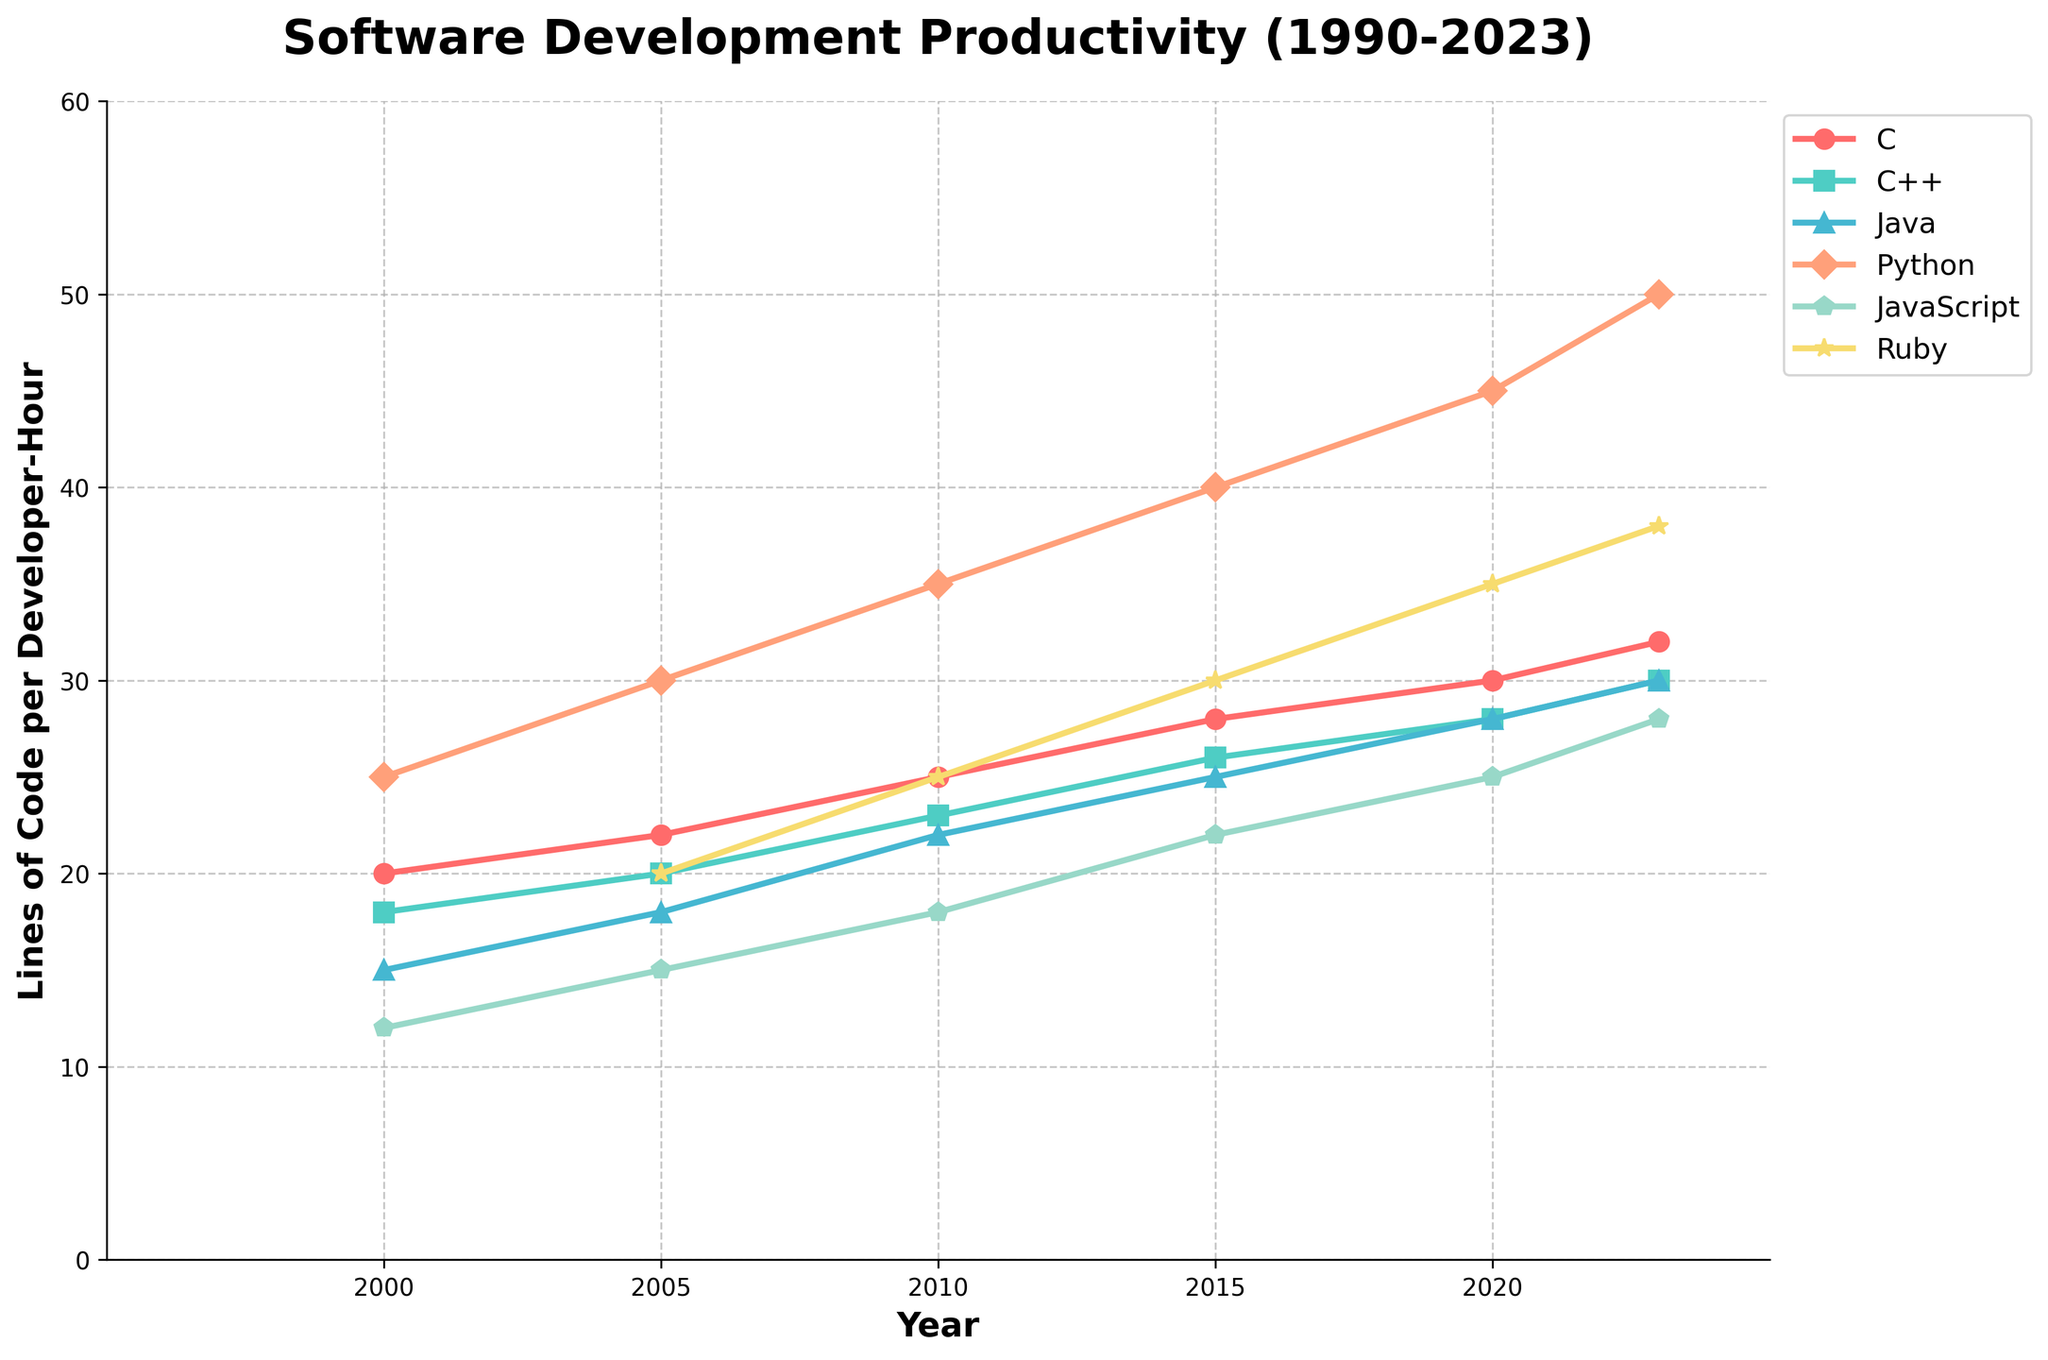What programming language shows the highest productivity in 2023? Locate the year 2023 on the x-axis and find the language with the highest value on the y-axis. Python shows the highest productivity at 50 lines of code per developer-hour.
Answer: Python How did the productivity of JavaScript change from 2000 to 2023? Identify the values for JavaScript in 2000 and 2023. In 2000, it was 12 lines of code per developer-hour, and in 2023, it increased to 28 lines of code per developer-hour. This shows a growth of 16 lines.
Answer: Increased by 16 lines Which programming language had the least productivity growth from 2000 to 2023? Determine the productivity value for each language in 2000 and 2023 and calculate the difference. For C: 32-20 = 12, C++: 30-18 = 12, Java: 30-15 = 15, Python: 50-25 = 25, JavaScript: 28-12 = 16, Ruby: 38-20 = 18. C and C++ both had the least growth of 12 lines each.
Answer: C and C++ Which programming language had the most significant increase in productivity between 2015 and 2020? Locate the years 2015 and 2020 on the x-axis and find the difference for each language. For C: 30-28 = 2, C++: 28-26 = 2, Java: 28-25 = 3, Python: 45-40 = 5, JavaScript: 25-22 = 3, Ruby: 35-30 = 5. Python and Ruby both show an increase of 5 lines.
Answer: Python and Ruby In what year did JavaScript reach a productivity level of 25 lines of code per developer-hour? Locate the y-axis value 25 for JavaScript and trace it back to the corresponding year on the x-axis, which is between 2015 and 2020. This indicates that JavaScript reached 25 lines of code per developer-hour in 2020.
Answer: 2020 What is the average productivity value of Ruby from 2005 to 2023? Identify the productivity values for Ruby in 2005, 2010, 2015, 2020, and 2023: 20, 25, 30, 35, and 38. Sum these values: 20 + 25 + 30 + 35 + 38 = 148. Divide by the number of data points, 148 / 5 = 29.6.
Answer: 29.6 Which programming language showed a notable linear growth in productivity over the years 2000 to 2023? Determine which lines closely follow a straight-upward trend. Python and Java show the most linear growth, increasing consistently over the years.
Answer: Python and Java 